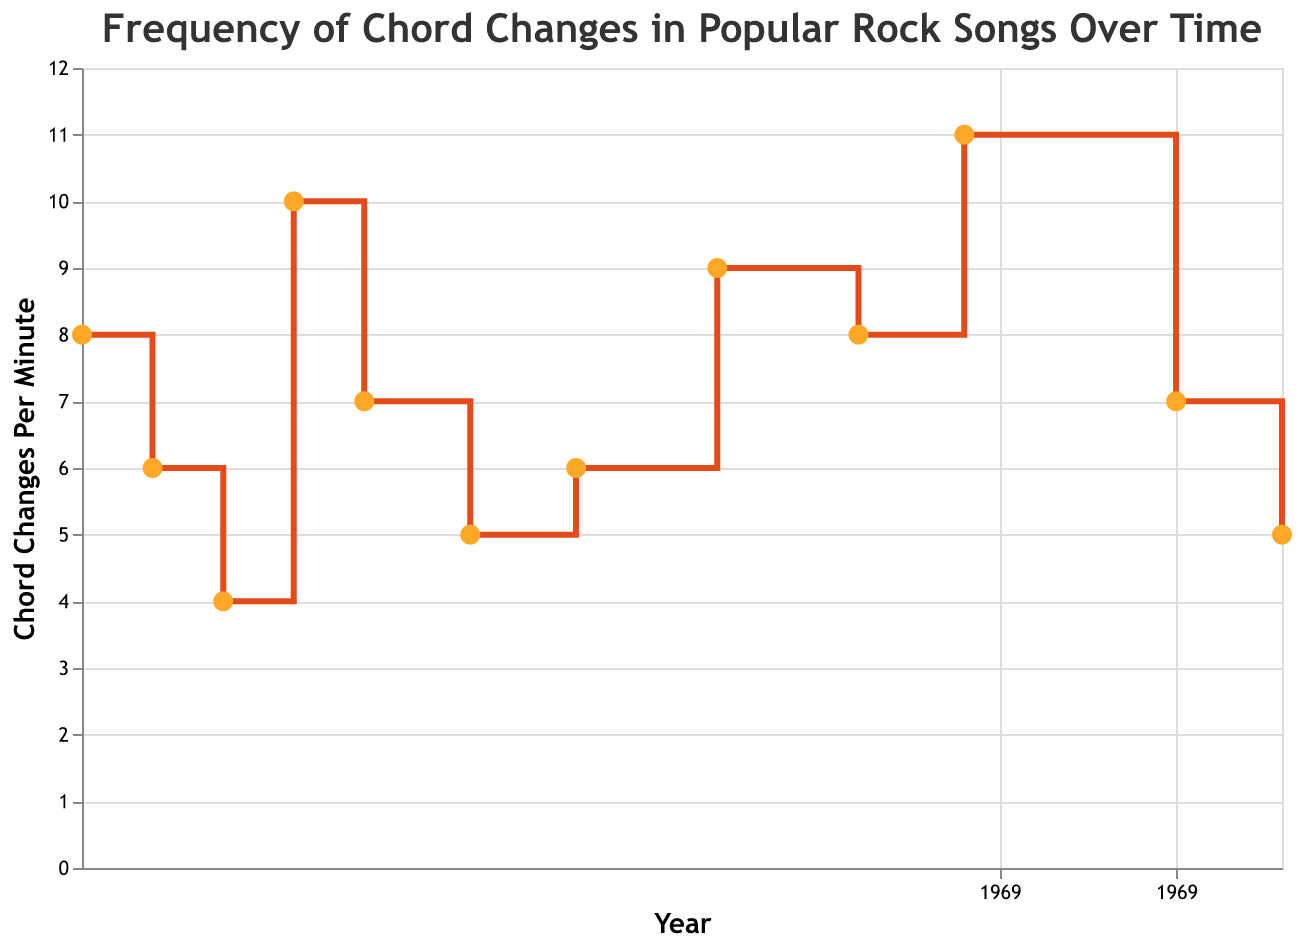How many data points are plotted on the figure? The data points represent the frequency of chord changes in popular rock songs over time. By counting the points, we see there are 12 data points representing years from 1969 to 2003.
Answer: 12 Which song has the highest frequency of chord changes per minute? The tooltip data shows that the song "Basket Case" by Green Day in 1994 has the highest chord changes per minute at 11.
Answer: "Basket Case" by Green Day What is the title of the figure? The title of the figure is specified at the top of the plot: "Frequency of Chord Changes in Popular Rock Songs Over Time".
Answer: Frequency of Chord Changes in Popular Rock Songs Over Time Between which two consecutive years is the largest increase in chord changes per minute observed? By observing the stair steps, the largest increase is between 1991 and 1994. The value increases from 8 to 11 (a difference of 3).
Answer: 1991 and 1994 How does the chord change frequency in "Hotel California" compare to "Money"? According to the plot, "Hotel California" (1977) has 7 chord changes per minute, while "Money" (1973) has 4 chord changes per minute. Thus, "Hotel California" has 3 more chord changes per minute than "Money".
Answer: "Hotel California" has 3 more chord changes per minute Find the average frequency of chord changes per minute for songs by Led Zeppelin. The plot includes two songs by Led Zeppelin: "Whole Lotta Love" with 8 chord changes per minute and "Stairway to Heaven" with 6. The average is calculated as (8 + 6) / 2 = 7.
Answer: 7 What general trend can be observed in the frequency of chord changes from 1969 to 2003? From the plot, it generally shows an increasing trend in chord changes per minute over the years, though there are fluctuations.
Answer: Increasing trend Which song released in the 2000s has a lower chord change frequency, and what is its value? The two songs from the 2000s are "Californication" (2000) with 7 chord changes per minute and "Seven Nation Army" (2003) with 5. "Seven Nation Army" has a lower frequency.
Answer: "Seven Nation Army" with 5 chord changes per minute 